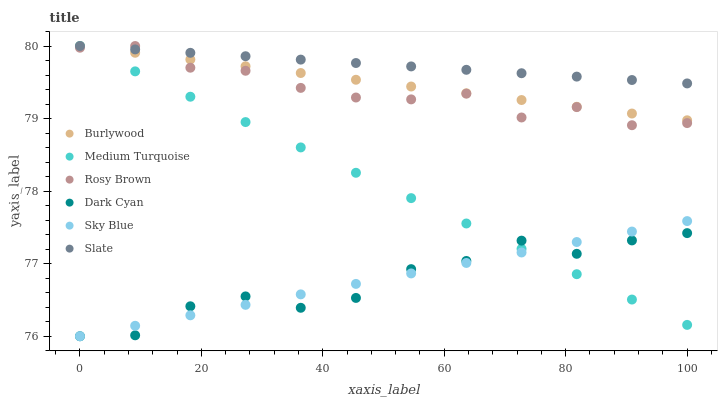Does Dark Cyan have the minimum area under the curve?
Answer yes or no. Yes. Does Slate have the maximum area under the curve?
Answer yes or no. Yes. Does Rosy Brown have the minimum area under the curve?
Answer yes or no. No. Does Rosy Brown have the maximum area under the curve?
Answer yes or no. No. Is Burlywood the smoothest?
Answer yes or no. Yes. Is Dark Cyan the roughest?
Answer yes or no. Yes. Is Slate the smoothest?
Answer yes or no. No. Is Slate the roughest?
Answer yes or no. No. Does Dark Cyan have the lowest value?
Answer yes or no. Yes. Does Rosy Brown have the lowest value?
Answer yes or no. No. Does Medium Turquoise have the highest value?
Answer yes or no. Yes. Does Dark Cyan have the highest value?
Answer yes or no. No. Is Dark Cyan less than Slate?
Answer yes or no. Yes. Is Rosy Brown greater than Dark Cyan?
Answer yes or no. Yes. Does Sky Blue intersect Medium Turquoise?
Answer yes or no. Yes. Is Sky Blue less than Medium Turquoise?
Answer yes or no. No. Is Sky Blue greater than Medium Turquoise?
Answer yes or no. No. Does Dark Cyan intersect Slate?
Answer yes or no. No. 